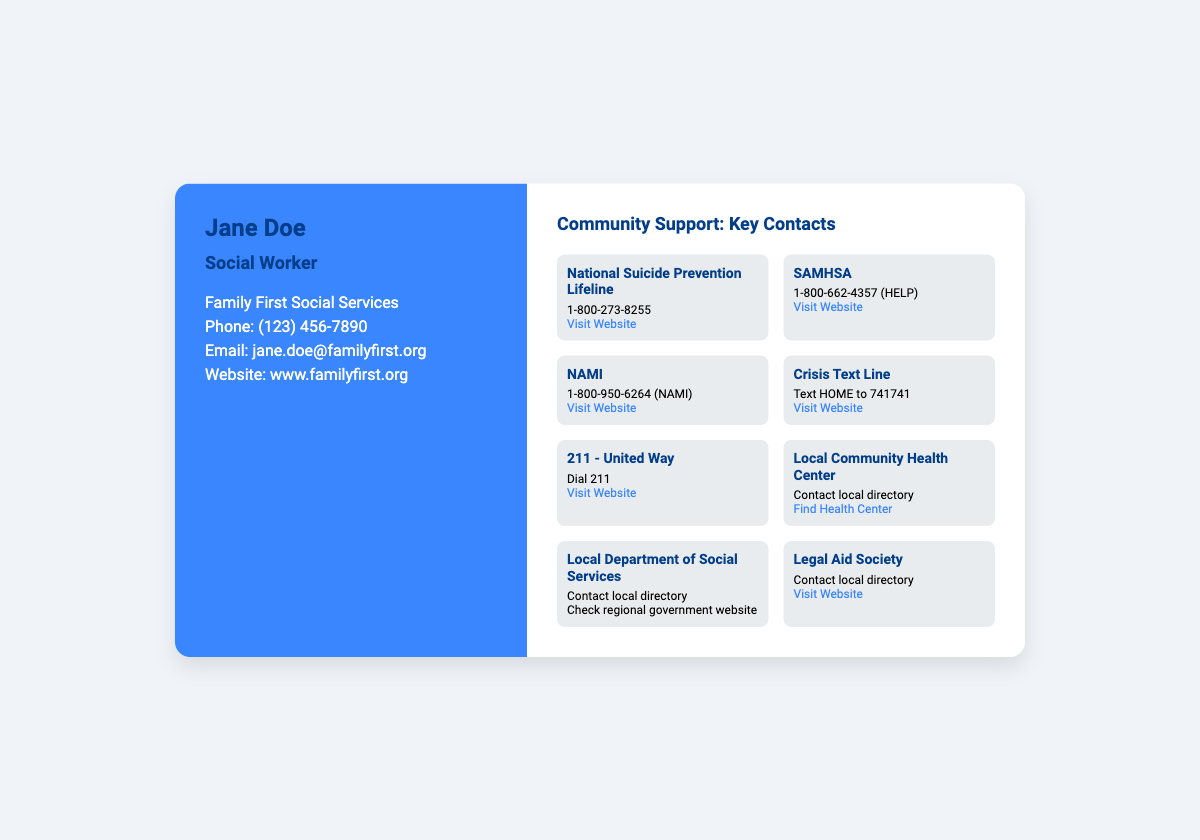what is the name of the social worker? The name of the social worker is prominently displayed at the top of the business card.
Answer: Jane Doe what is the primary organization listed on the card? The organization where the social worker is employed is mentioned in the contact info section.
Answer: Family First Social Services what is the phone number provided for the social worker? The card displays a specific phone number for contact purposes under the contact info section.
Answer: (123) 456-7890 what is the number for the National Suicide Prevention Lifeline? This is a specific helpline mentioned among the key contacts for community support.
Answer: 1-800-273-8255 how can you reach SAMHSA? SAMHSA's contact information is given, specifying a phone number for assistance.
Answer: 1-800-662-4357 (HELP) what type of assistance does NAMI provide? NAMI is listed as a key contact, indicating a focus on mental health support.
Answer: Mental health support which text should be sent to contact the Crisis Text Line? The document specifies a brief instruction for reaching out to the Crisis Text Line.
Answer: Text HOME what is the website for the Legal Aid Society? The business card provides a URL that directs to the Legal Aid Society's resources.
Answer: www.legalaid.org how can you find a local health center? The document indicates a method for locating a health center through a specific URL.
Answer: Find Health Center 